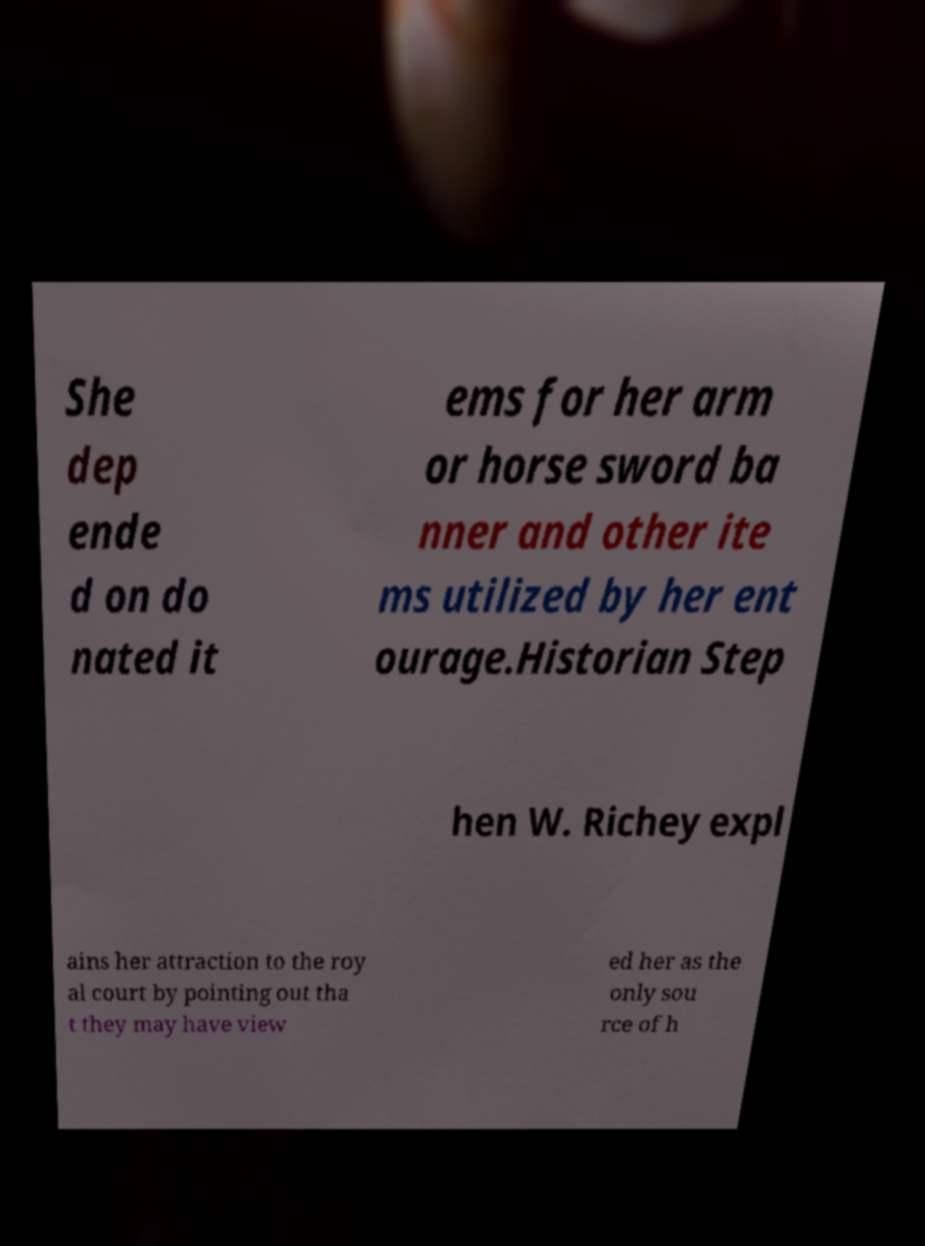Could you extract and type out the text from this image? She dep ende d on do nated it ems for her arm or horse sword ba nner and other ite ms utilized by her ent ourage.Historian Step hen W. Richey expl ains her attraction to the roy al court by pointing out tha t they may have view ed her as the only sou rce of h 